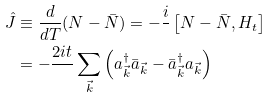Convert formula to latex. <formula><loc_0><loc_0><loc_500><loc_500>\hat { J } & \equiv \frac { d } { d T } ( N - \bar { N } ) = - \frac { i } { } \left [ N - \bar { N } , H _ { t } \right ] \\ & = - \frac { 2 i t } { } \sum _ { \vec { k } } \left ( a _ { \vec { k } } ^ { \dagger } \bar { a } _ { \vec { k } } - \bar { a } _ { \vec { k } } ^ { \dagger } a _ { \vec { k } } \right )</formula> 